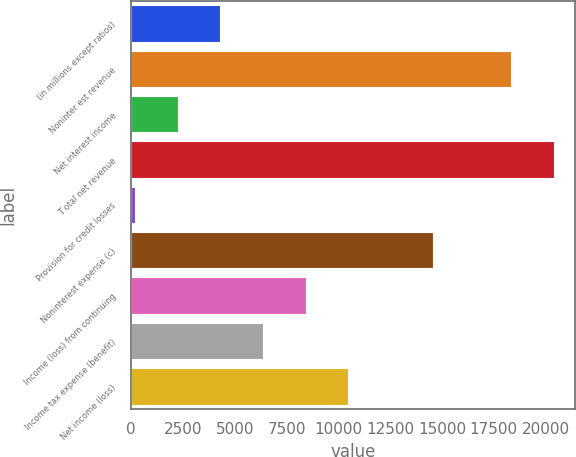Convert chart. <chart><loc_0><loc_0><loc_500><loc_500><bar_chart><fcel>(in millions except ratios)<fcel>Noninter est revenue<fcel>Net interest income<fcel>T otal net revenue<fcel>Provision for credit losses<fcel>Noninterest expense (c)<fcel>Income (loss) from continuing<fcel>Income tax expense (benefit)<fcel>Net income (loss)<nl><fcel>4303.4<fcel>18334<fcel>2247.2<fcel>20390.2<fcel>191<fcel>14584.4<fcel>8415.8<fcel>6359.6<fcel>10472<nl></chart> 